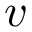Convert formula to latex. <formula><loc_0><loc_0><loc_500><loc_500>v</formula> 